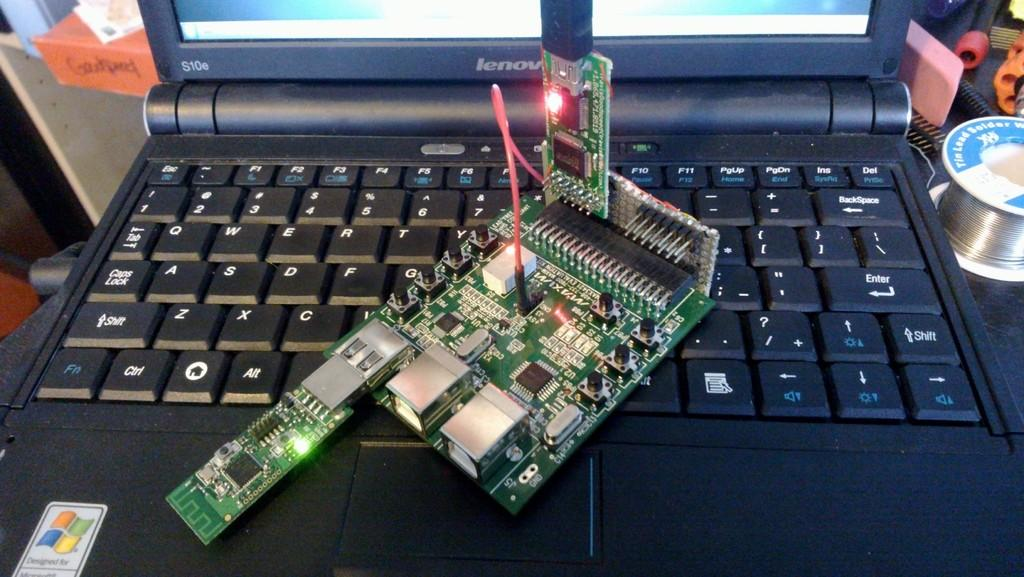Provide a one-sentence caption for the provided image. A Lenovo laptop model S10e is being worked on. 